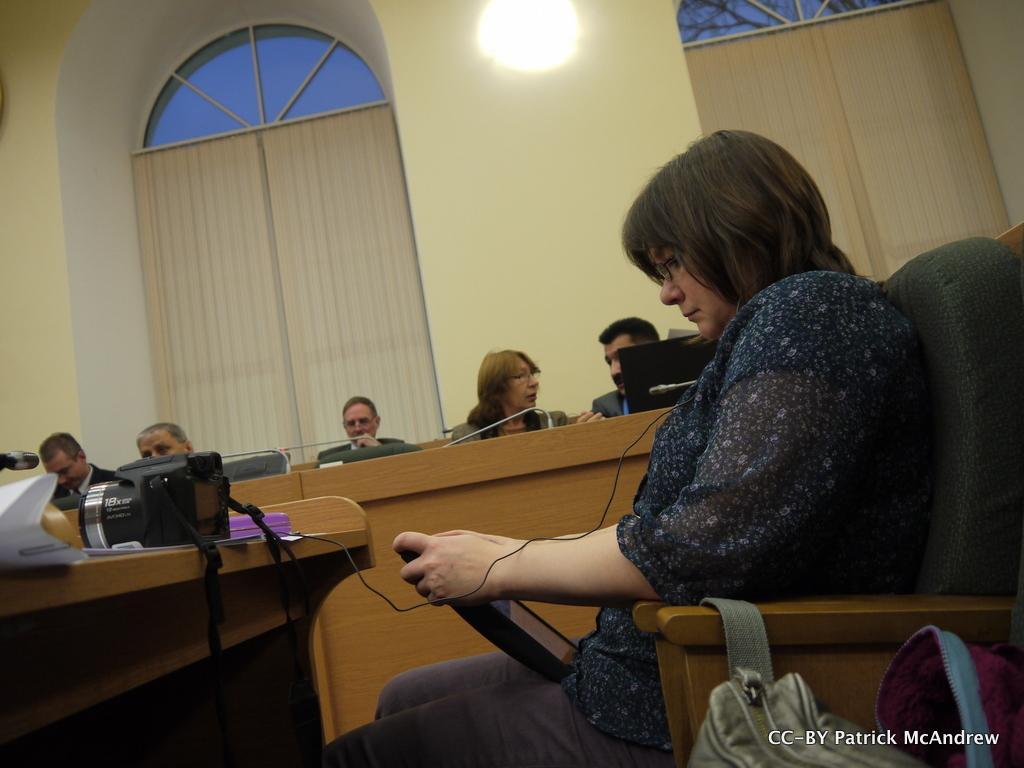In one or two sentences, can you explain what this image depicts? In the picture I can see a woman sitting on the wooden chair and she is holding an electronic device in her hands. I can see the bags on the bottom right side. There is a wooden table on the left side and I can see a camera on the wooden table. In the background, I can see a few persons and they are having a conversation. In the background, I can see the window blinds and glass windows. 